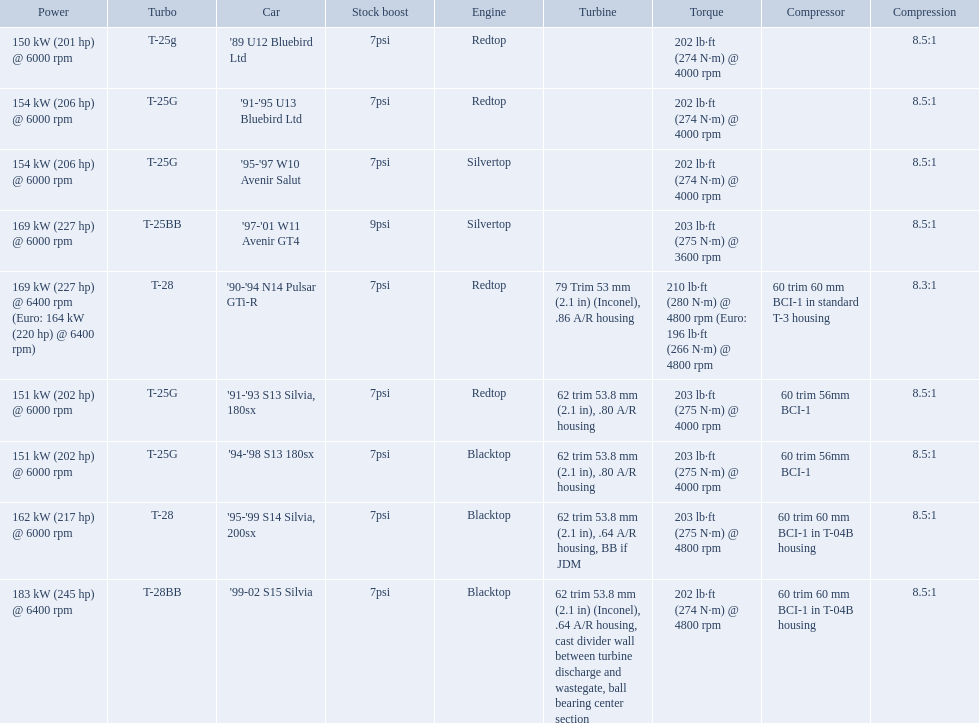What are all of the cars? '89 U12 Bluebird Ltd, '91-'95 U13 Bluebird Ltd, '95-'97 W10 Avenir Salut, '97-'01 W11 Avenir GT4, '90-'94 N14 Pulsar GTi-R, '91-'93 S13 Silvia, 180sx, '94-'98 S13 180sx, '95-'99 S14 Silvia, 200sx, '99-02 S15 Silvia. What is their rated power? 150 kW (201 hp) @ 6000 rpm, 154 kW (206 hp) @ 6000 rpm, 154 kW (206 hp) @ 6000 rpm, 169 kW (227 hp) @ 6000 rpm, 169 kW (227 hp) @ 6400 rpm (Euro: 164 kW (220 hp) @ 6400 rpm), 151 kW (202 hp) @ 6000 rpm, 151 kW (202 hp) @ 6000 rpm, 162 kW (217 hp) @ 6000 rpm, 183 kW (245 hp) @ 6400 rpm. Which car has the most power? '99-02 S15 Silvia. What are the psi's? 7psi, 7psi, 7psi, 9psi, 7psi, 7psi, 7psi, 7psi, 7psi. What are the number(s) greater than 7? 9psi. Which car has that number? '97-'01 W11 Avenir GT4. What are all the cars? '89 U12 Bluebird Ltd, '91-'95 U13 Bluebird Ltd, '95-'97 W10 Avenir Salut, '97-'01 W11 Avenir GT4, '90-'94 N14 Pulsar GTi-R, '91-'93 S13 Silvia, 180sx, '94-'98 S13 180sx, '95-'99 S14 Silvia, 200sx, '99-02 S15 Silvia. What are their stock boosts? 7psi, 7psi, 7psi, 9psi, 7psi, 7psi, 7psi, 7psi, 7psi. And which car has the highest stock boost? '97-'01 W11 Avenir GT4. 